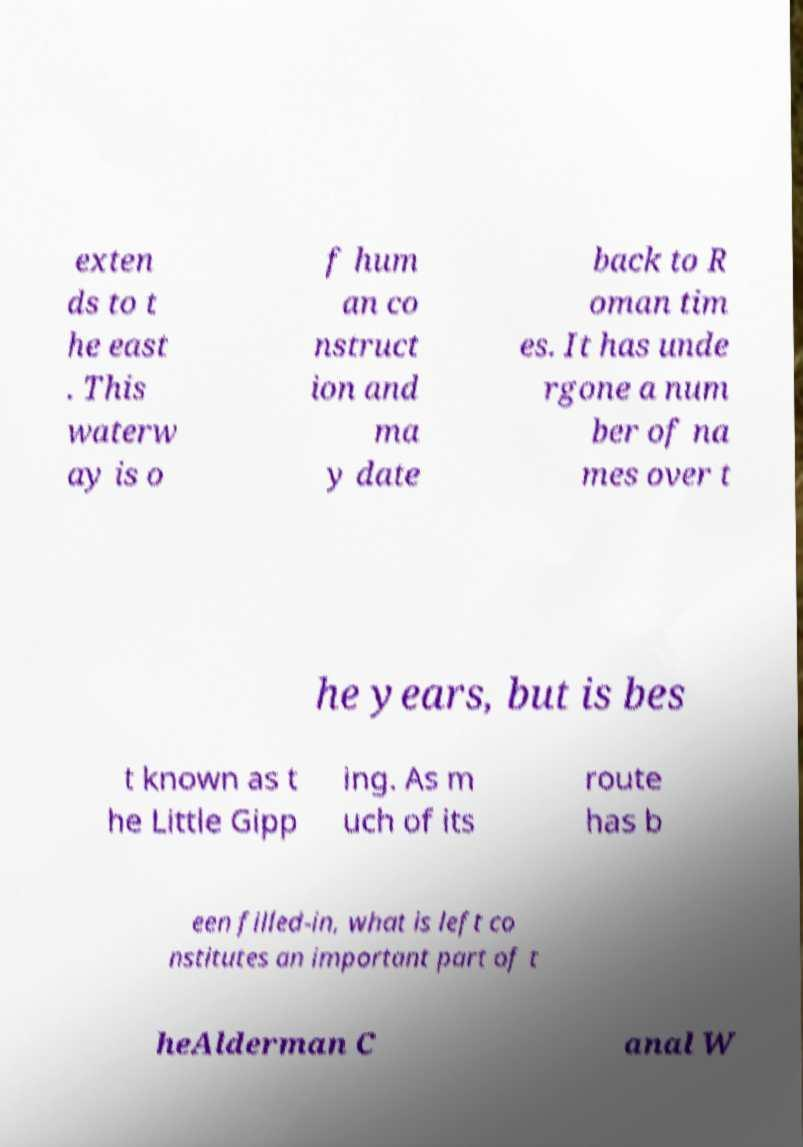Please read and relay the text visible in this image. What does it say? exten ds to t he east . This waterw ay is o f hum an co nstruct ion and ma y date back to R oman tim es. It has unde rgone a num ber of na mes over t he years, but is bes t known as t he Little Gipp ing. As m uch of its route has b een filled-in, what is left co nstitutes an important part of t heAlderman C anal W 